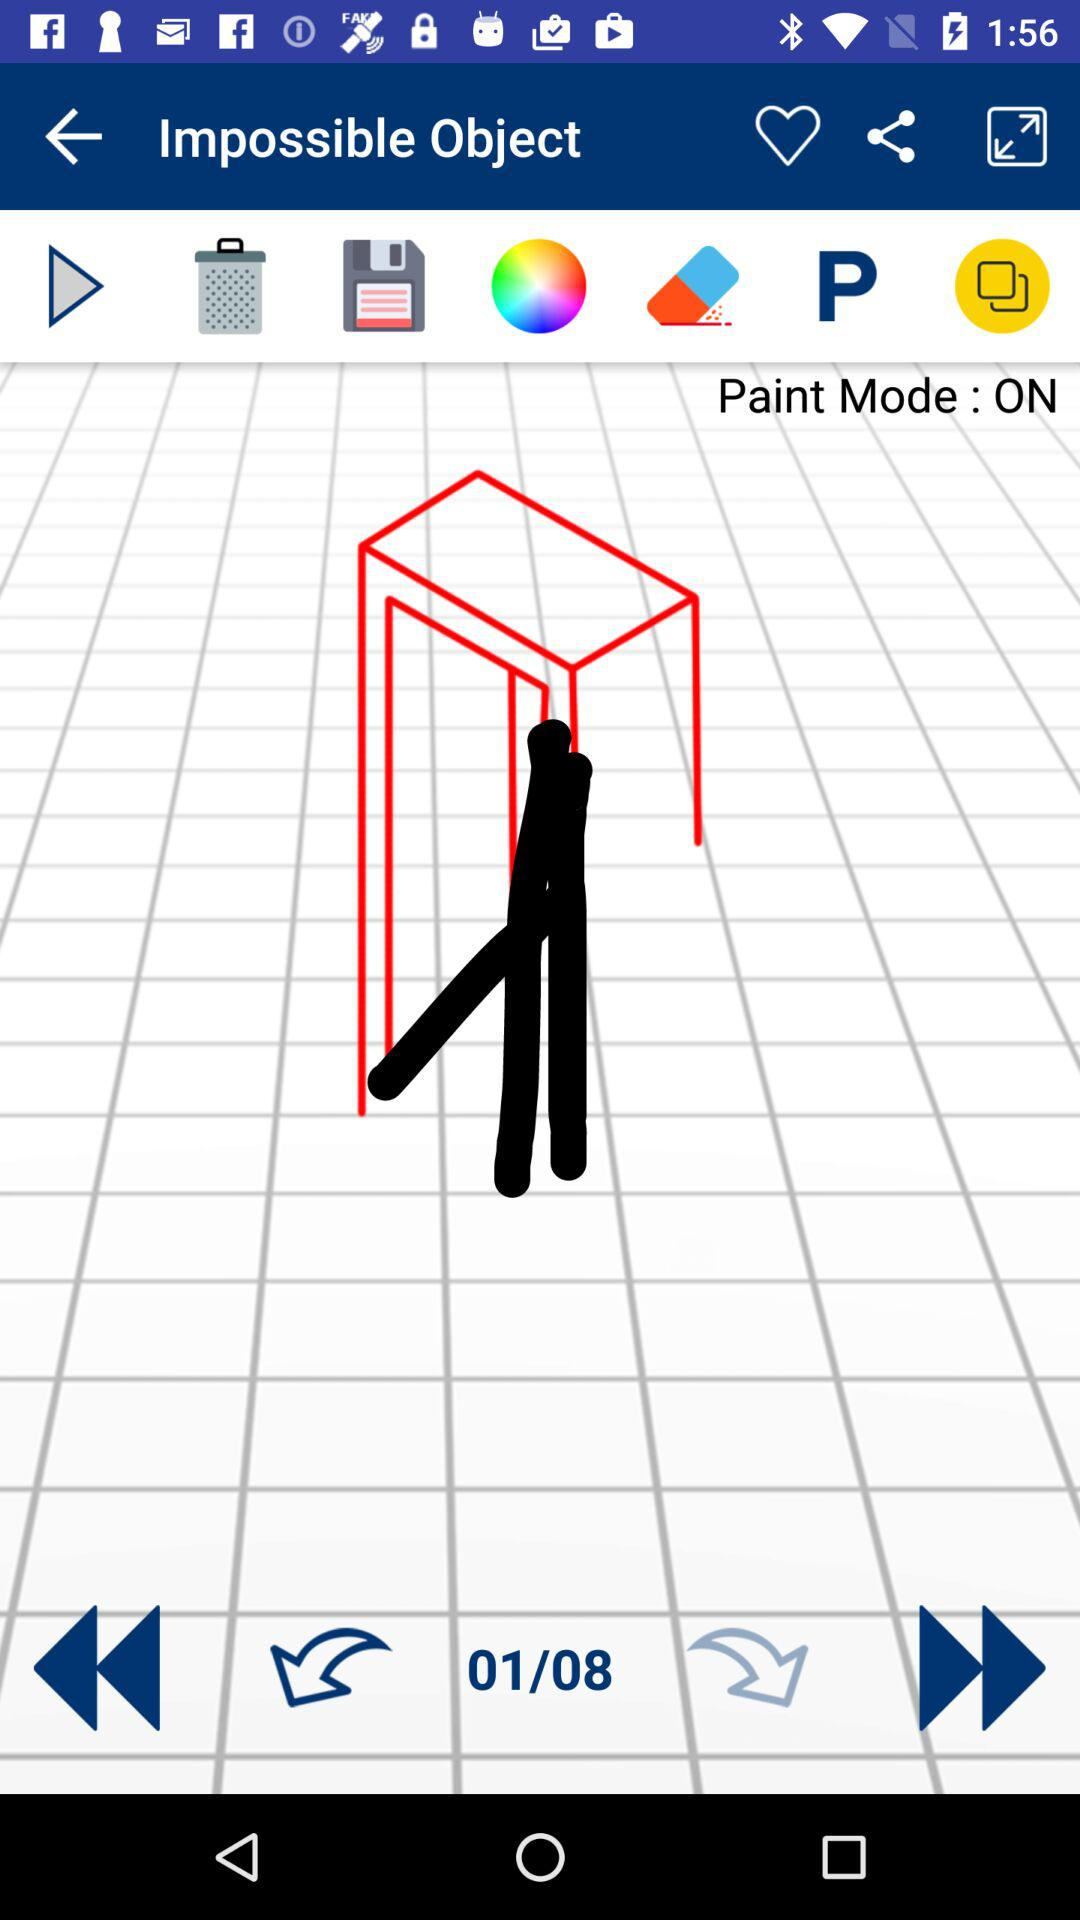What is the total number of slides? The total number of slides is 8. 